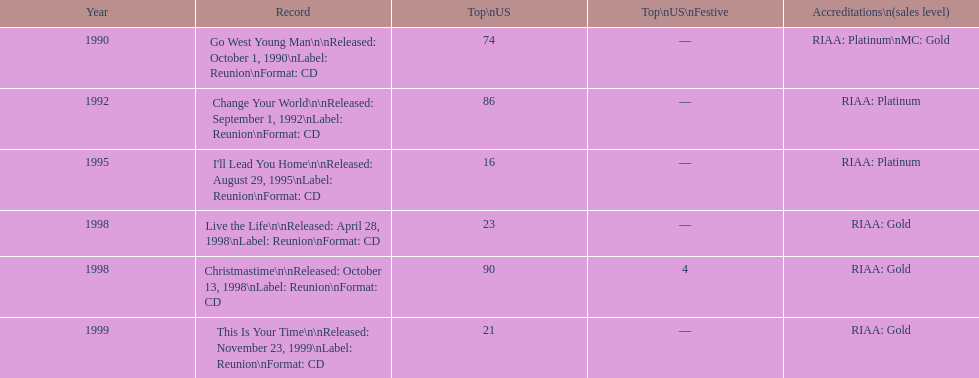The oldest year listed is what? 1990. 